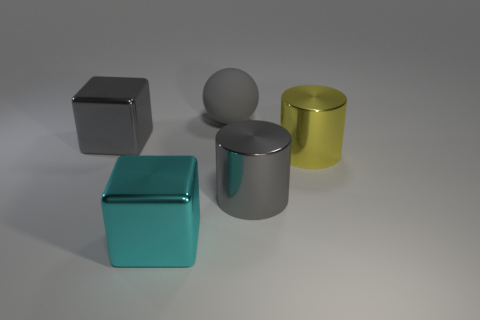What number of other objects are there of the same material as the sphere?
Provide a short and direct response. 0. Does the ball have the same size as the gray metallic cylinder?
Provide a succinct answer. Yes. How many objects are gray metallic things to the right of the gray sphere or large yellow shiny cubes?
Provide a succinct answer. 1. The big gray thing that is in front of the gray shiny object that is left of the big matte thing is made of what material?
Provide a succinct answer. Metal. Are there any tiny metal things of the same shape as the big yellow thing?
Offer a terse response. No. There is a gray rubber ball; does it have the same size as the metal object in front of the gray cylinder?
Offer a very short reply. Yes. How many things are either metal blocks behind the cyan metal block or gray blocks that are to the left of the large cyan cube?
Give a very brief answer. 1. Is the number of gray cubes behind the rubber thing greater than the number of large blocks?
Your response must be concise. No. How many matte balls are the same size as the cyan thing?
Make the answer very short. 1. There is a gray object that is to the left of the big sphere; is its size the same as the gray metal thing to the right of the large cyan object?
Give a very brief answer. Yes. 